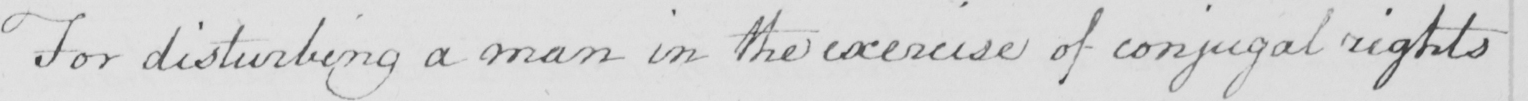Please provide the text content of this handwritten line. For disturbing a man in the exercise of conjugal rights 